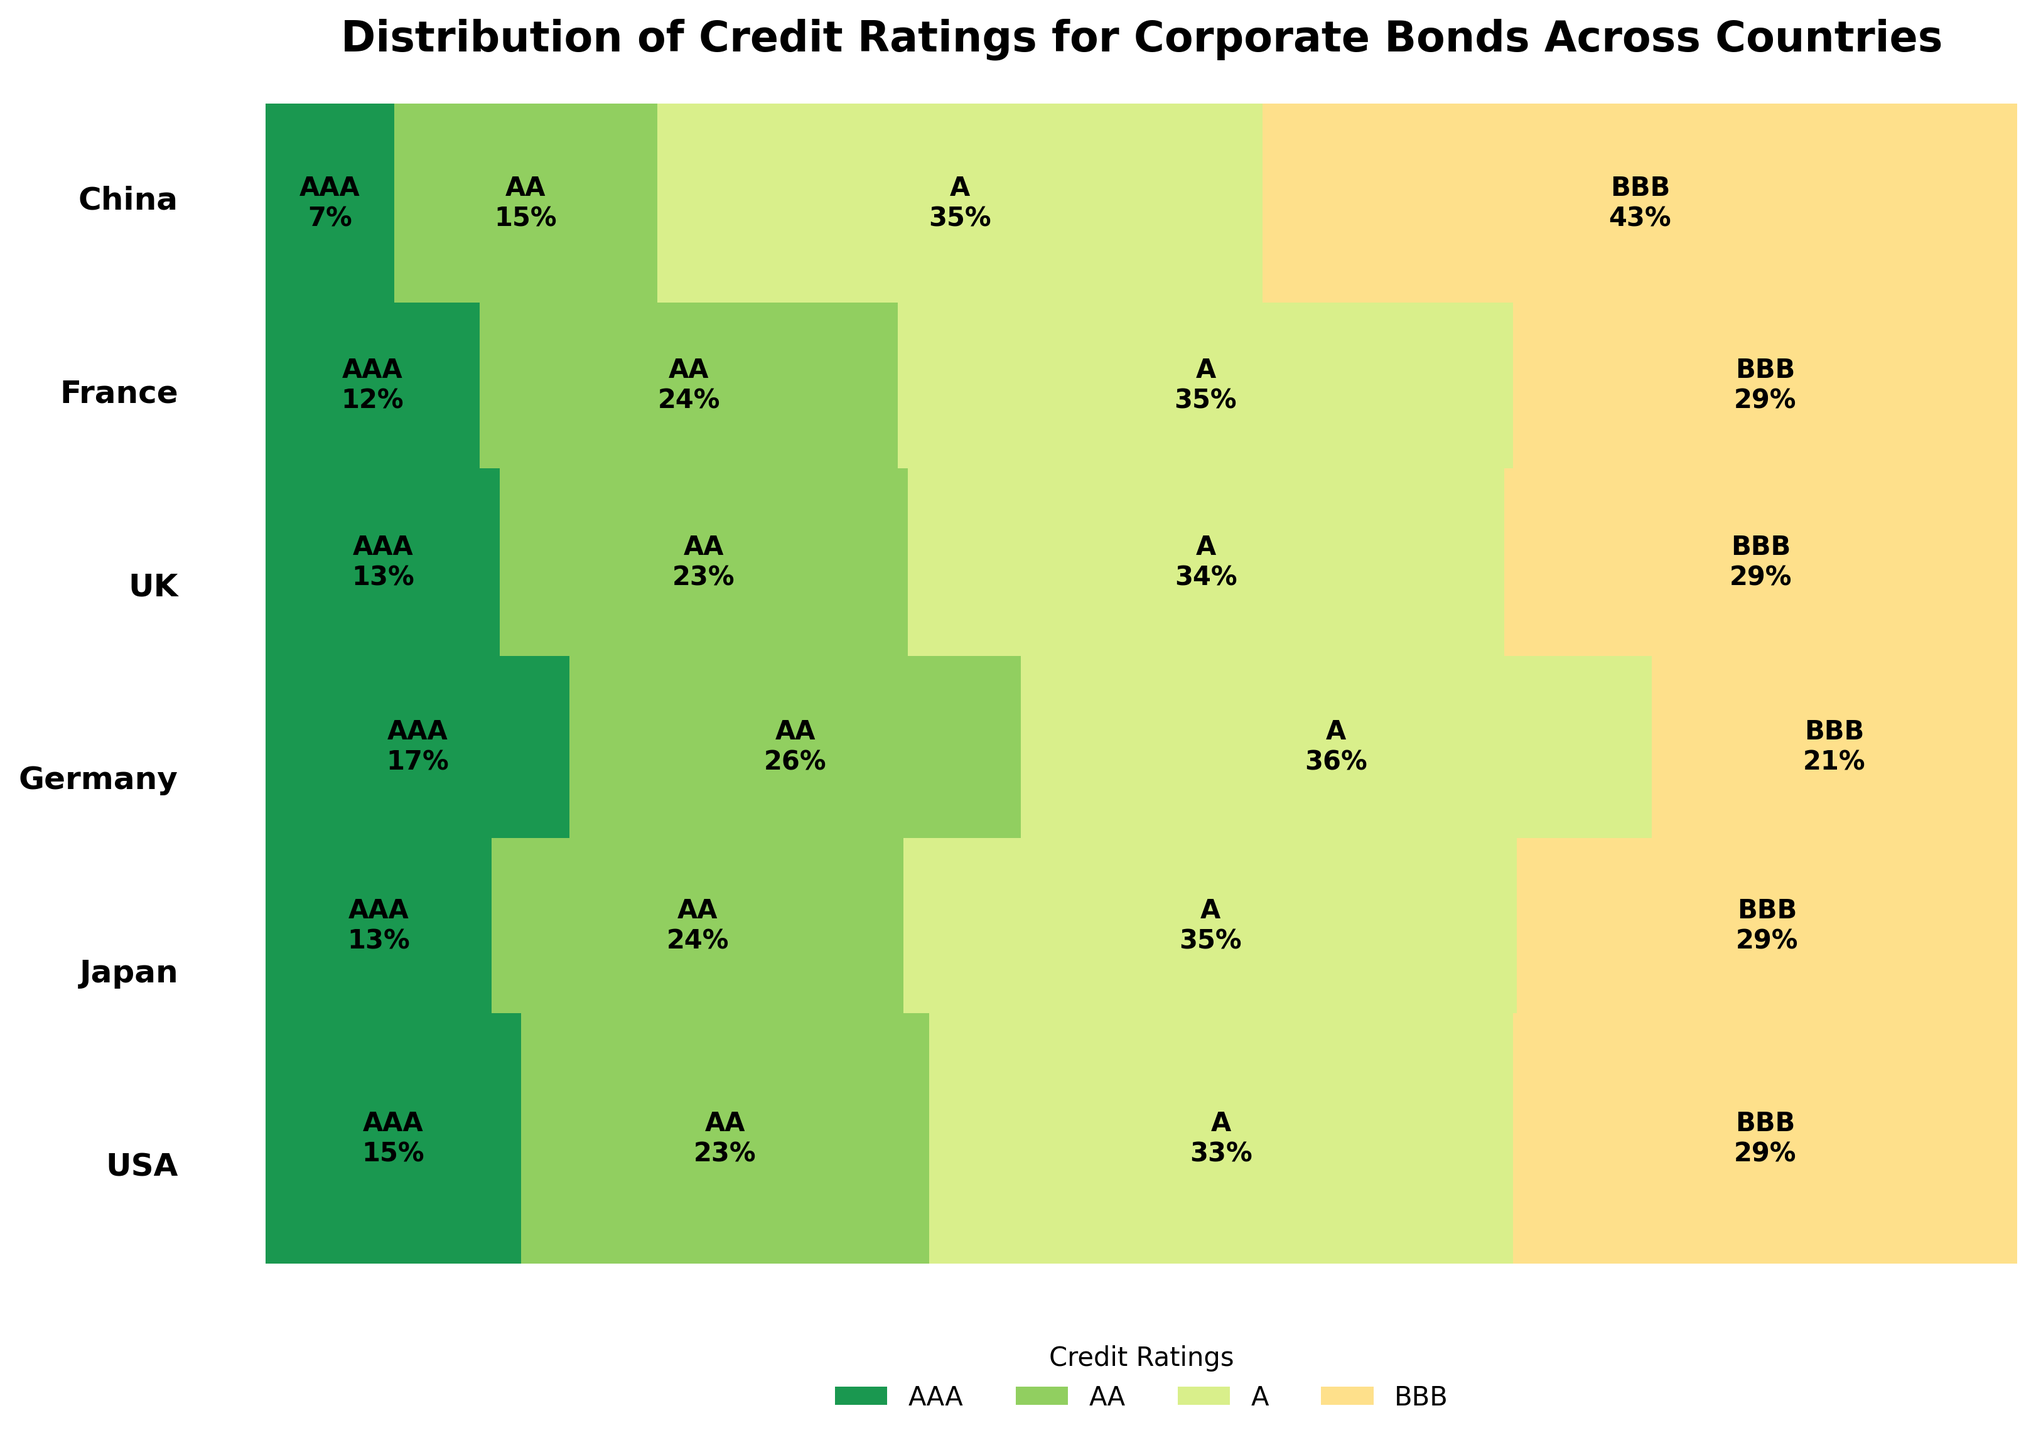What's the most common credit rating for corporate bonds in the USA? The largest section of the USA's segment on the mosaic plot is "A", which covers the highest portion of the rectangle that represents the USA.
Answer: A Which country has the highest proportion of BBB-rated corporate bonds? The segment for China has a notably larger portion dedicated to BBB-rated bonds compared to other countries.
Answer: China Between Germany and the UK, which country has a higher percentage of AA-rated bonds? By comparing the AA-rated sections in both countries' segments, Germany has a larger part dedicated to AA-rated bonds than the UK.
Answer: Germany What's the total proportion of AAA-rated bonds across all countries? To find this, sum up the proportions of AAA-rated sections across all country segments. USA (AAA) = 45, Japan (AAA) = 28, Germany (AAA) = 39, UK (AAA) = 31, France (AAA) = 25, China (AAA) = 18. Proportion = (45+28+39+31+25+18)/total. Total = sum of all counts (45+72+103+89+28+51+76+62+39+58+81+47+31+54+79+68+25+49+72+59+18+37+85+106) = 1248. Thus, AAA proportion = 186/1248.
Answer: 14.9% How does the proportion of AAA-rated bonds in Japan compare to that in Germany? Compare the height of the AAA-rated sections for Japan and Germany. Japan's AAA-rated bonds take a smaller portion compared to Germany's.
Answer: Germany has a higher proportion Which country has the smallest segment for AAA-rated corporate bonds? The segment for China has the smallest portion labeled as AAA compared to the other countries.
Answer: China What is the overall proportion of A-rated bonds? To calculate this, sum up the proportions of A-rated sections across all country segments. USA (A) = 103, Japan (A) = 76, Germany (A) = 81, UK (A) = 79, France (A) = 72, China (A) = 85. Proportion = (103+76+81+79+72+85)/total. Total = 1248 (previously calculated). Thus, A proportion = 496/1248.
Answer: 39.7% Which country has a more balanced distribution of credit ratings? By observing the mosaic plot, Germany appears to have relatively similar-sized sections for each credit rating compared to other countries, indicating a more balanced distribution.
Answer: Germany How does the proportion of AA-rated bonds in France compare to that in the USA? Compare the AA-rated sections for both countries. France’s AA-rated portion is smaller than that of the USA.
Answer: USA has a higher proportion 